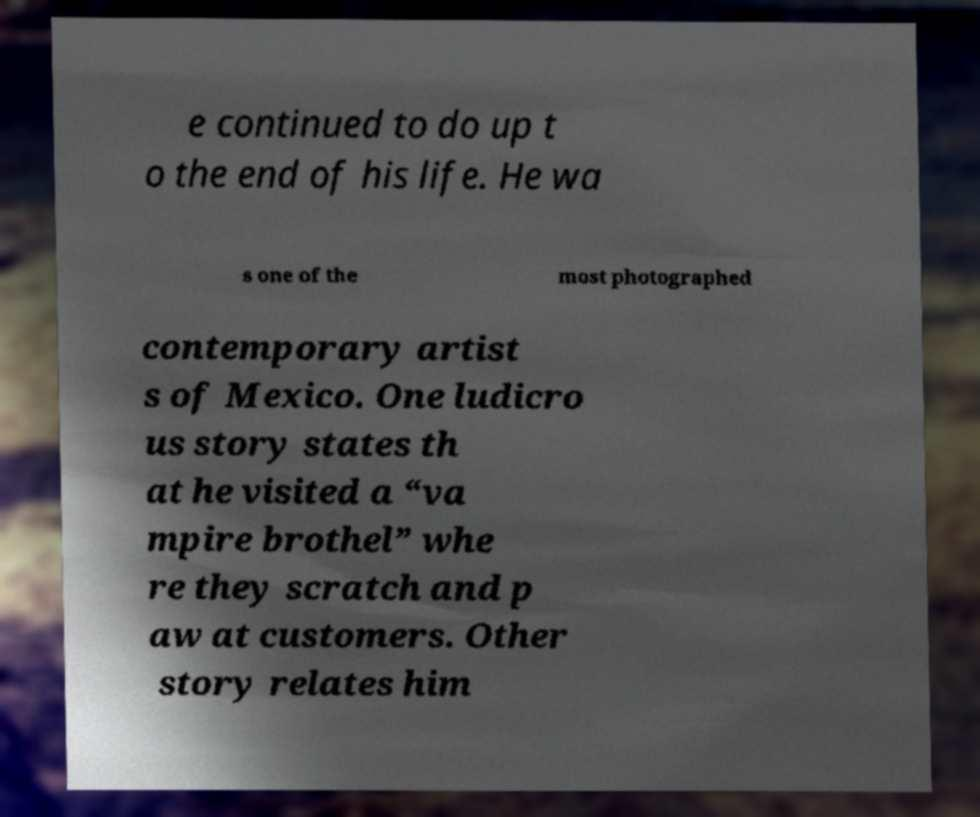Can you read and provide the text displayed in the image?This photo seems to have some interesting text. Can you extract and type it out for me? e continued to do up t o the end of his life. He wa s one of the most photographed contemporary artist s of Mexico. One ludicro us story states th at he visited a “va mpire brothel” whe re they scratch and p aw at customers. Other story relates him 